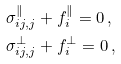<formula> <loc_0><loc_0><loc_500><loc_500>& \sigma ^ { \| } _ { i j , j } + f _ { i } ^ { \| } = 0 \, , \\ & \sigma ^ { \bot } _ { i j , j } + f _ { i } ^ { \bot } = 0 \, ,</formula> 